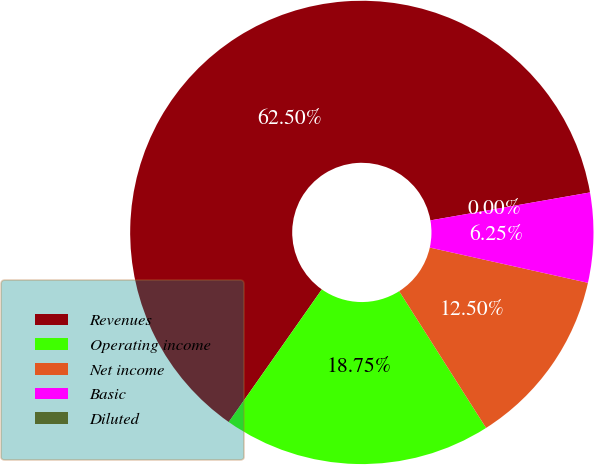<chart> <loc_0><loc_0><loc_500><loc_500><pie_chart><fcel>Revenues<fcel>Operating income<fcel>Net income<fcel>Basic<fcel>Diluted<nl><fcel>62.5%<fcel>18.75%<fcel>12.5%<fcel>6.25%<fcel>0.0%<nl></chart> 